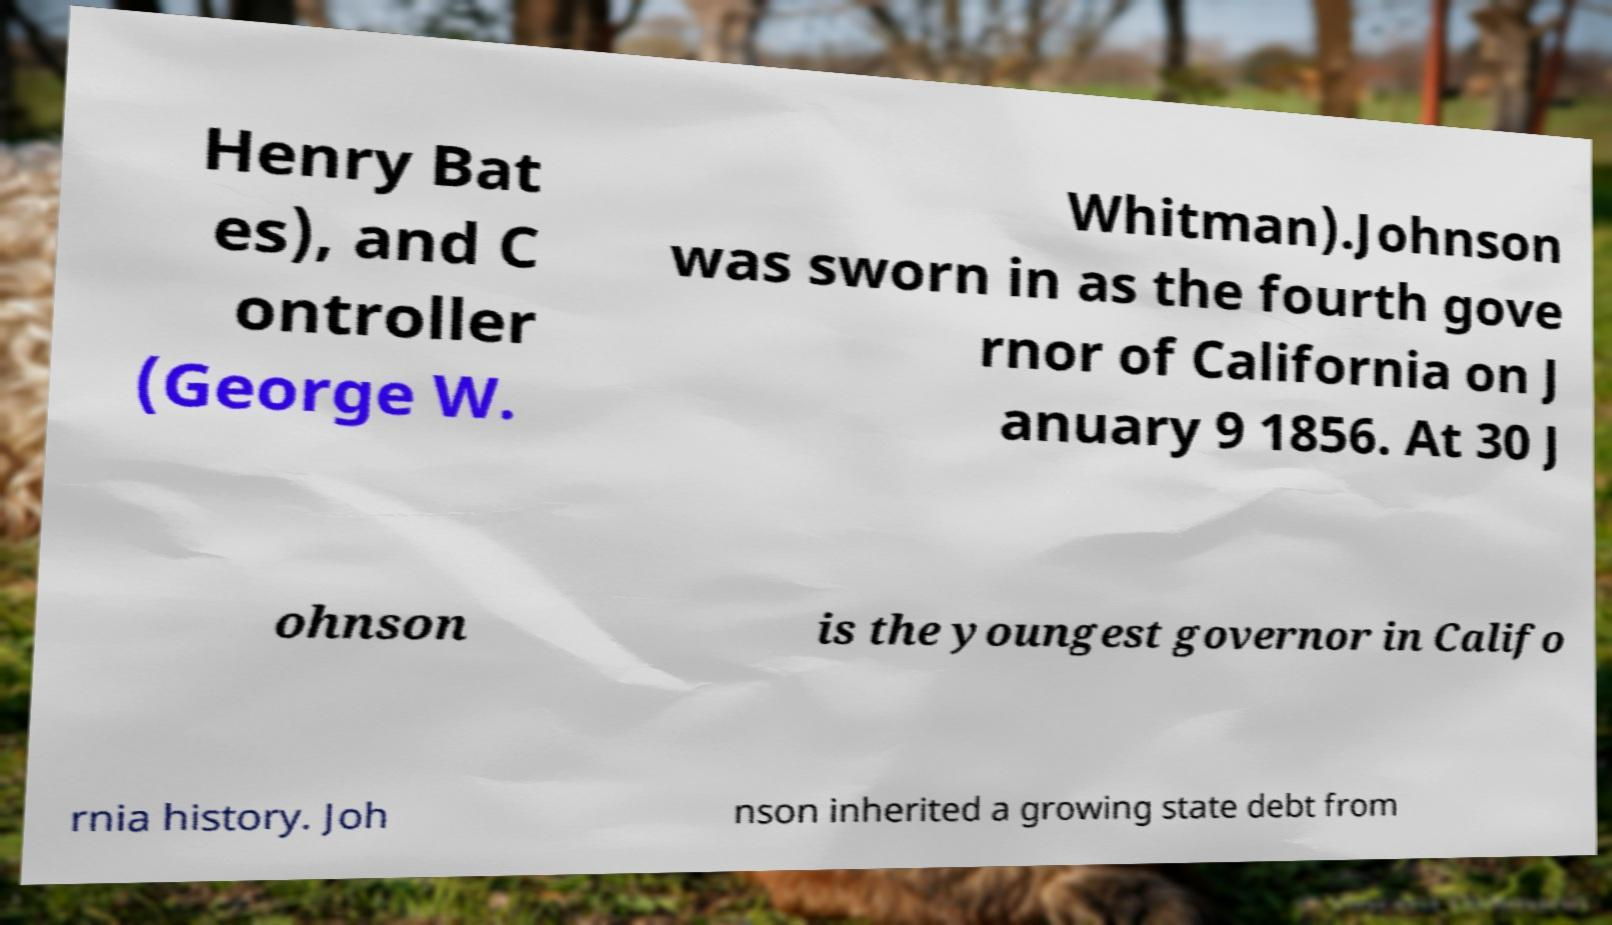Please identify and transcribe the text found in this image. Henry Bat es), and C ontroller (George W. Whitman).Johnson was sworn in as the fourth gove rnor of California on J anuary 9 1856. At 30 J ohnson is the youngest governor in Califo rnia history. Joh nson inherited a growing state debt from 